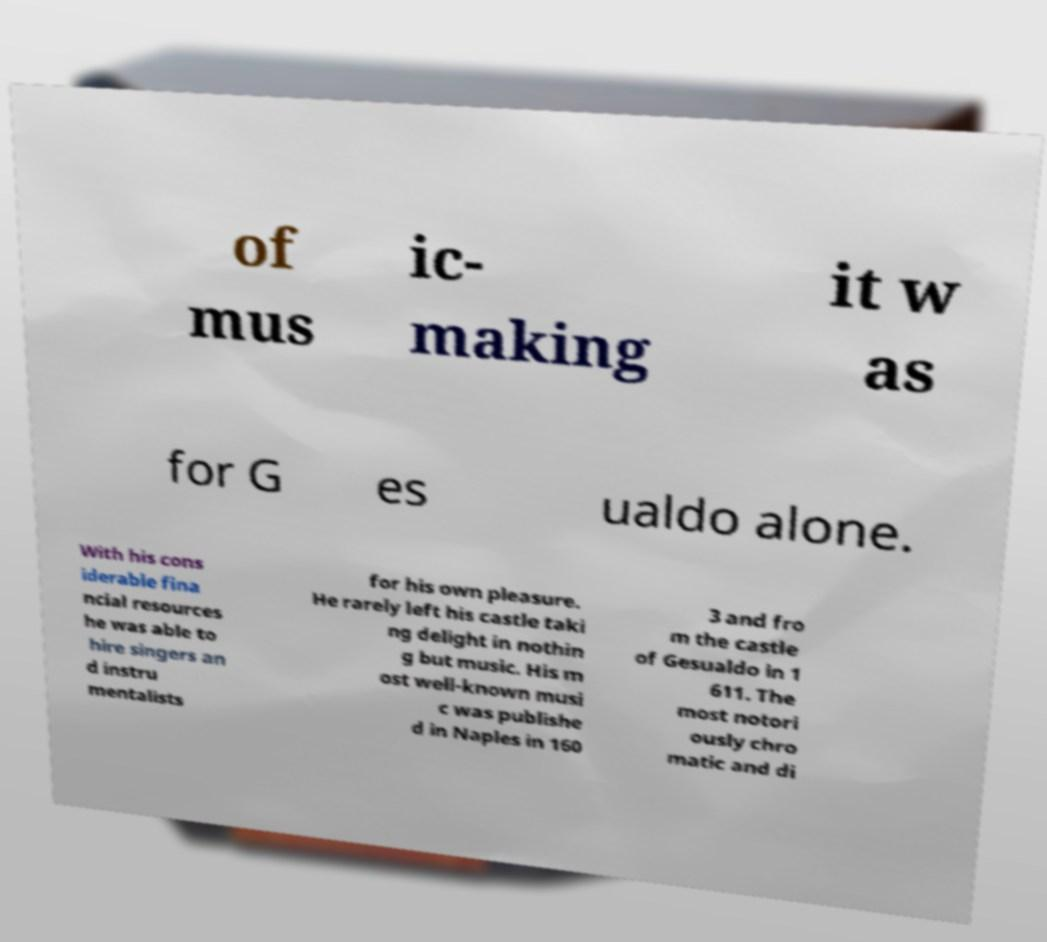For documentation purposes, I need the text within this image transcribed. Could you provide that? of mus ic- making it w as for G es ualdo alone. With his cons iderable fina ncial resources he was able to hire singers an d instru mentalists for his own pleasure. He rarely left his castle taki ng delight in nothin g but music. His m ost well-known musi c was publishe d in Naples in 160 3 and fro m the castle of Gesualdo in 1 611. The most notori ously chro matic and di 